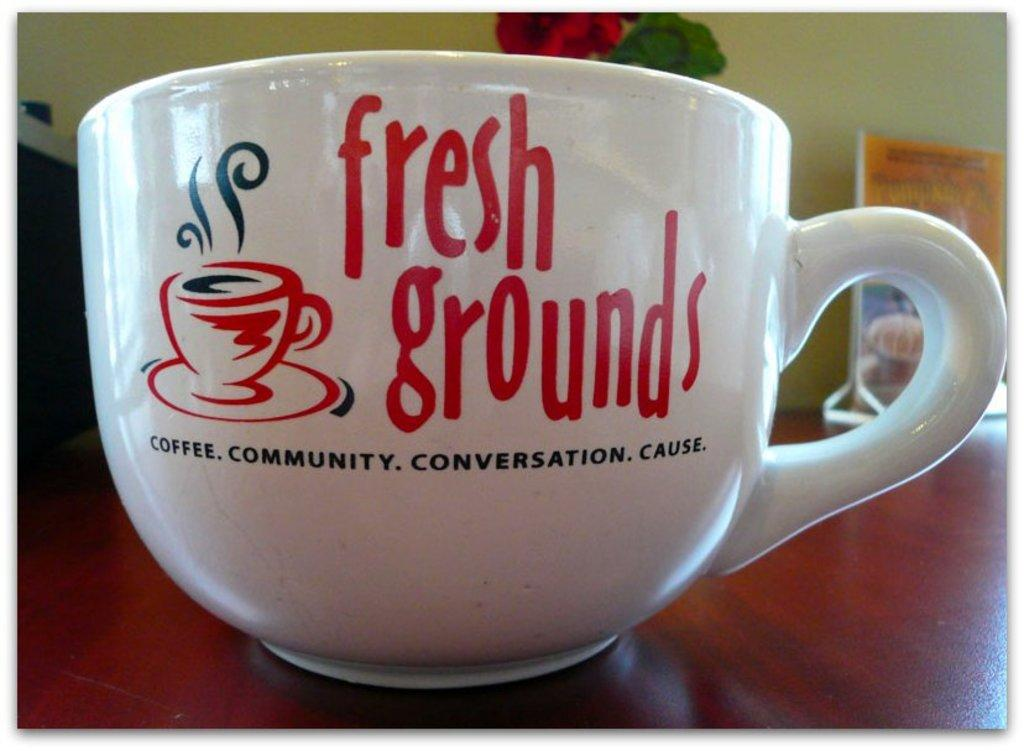Provide a one-sentence caption for the provided image. A large cappucino mug that says fresh grounds. 